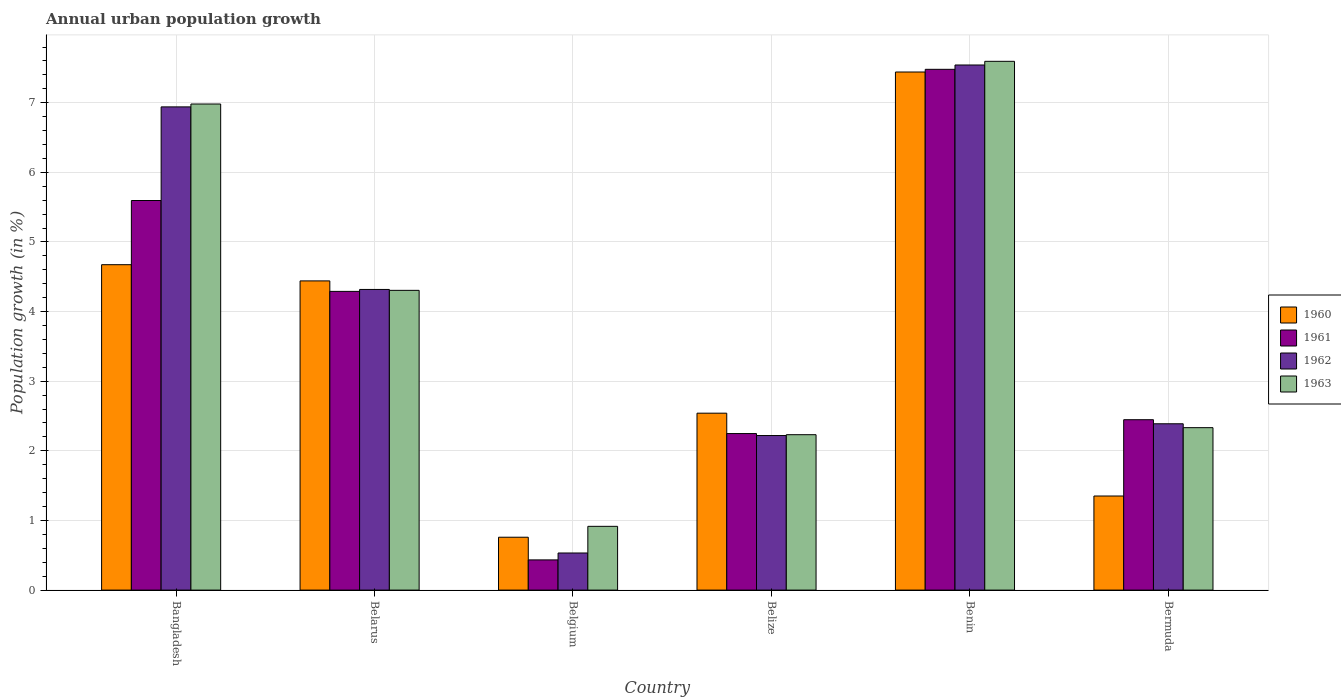Are the number of bars per tick equal to the number of legend labels?
Your response must be concise. Yes. Are the number of bars on each tick of the X-axis equal?
Provide a short and direct response. Yes. How many bars are there on the 2nd tick from the right?
Offer a very short reply. 4. What is the label of the 4th group of bars from the left?
Your answer should be compact. Belize. In how many cases, is the number of bars for a given country not equal to the number of legend labels?
Your answer should be compact. 0. What is the percentage of urban population growth in 1963 in Belarus?
Offer a very short reply. 4.31. Across all countries, what is the maximum percentage of urban population growth in 1963?
Offer a very short reply. 7.59. Across all countries, what is the minimum percentage of urban population growth in 1962?
Give a very brief answer. 0.53. In which country was the percentage of urban population growth in 1960 maximum?
Provide a succinct answer. Benin. In which country was the percentage of urban population growth in 1961 minimum?
Your answer should be compact. Belgium. What is the total percentage of urban population growth in 1963 in the graph?
Provide a short and direct response. 24.36. What is the difference between the percentage of urban population growth in 1963 in Bangladesh and that in Belarus?
Ensure brevity in your answer.  2.68. What is the difference between the percentage of urban population growth in 1960 in Belarus and the percentage of urban population growth in 1962 in Benin?
Offer a terse response. -3.1. What is the average percentage of urban population growth in 1962 per country?
Your answer should be very brief. 3.99. What is the difference between the percentage of urban population growth of/in 1962 and percentage of urban population growth of/in 1960 in Bangladesh?
Provide a short and direct response. 2.27. What is the ratio of the percentage of urban population growth in 1963 in Belize to that in Bermuda?
Give a very brief answer. 0.96. What is the difference between the highest and the second highest percentage of urban population growth in 1963?
Provide a short and direct response. -2.68. What is the difference between the highest and the lowest percentage of urban population growth in 1960?
Provide a short and direct response. 6.68. In how many countries, is the percentage of urban population growth in 1960 greater than the average percentage of urban population growth in 1960 taken over all countries?
Offer a terse response. 3. Is the sum of the percentage of urban population growth in 1960 in Belgium and Bermuda greater than the maximum percentage of urban population growth in 1961 across all countries?
Give a very brief answer. No. How many bars are there?
Make the answer very short. 24. Are all the bars in the graph horizontal?
Your answer should be compact. No. Does the graph contain grids?
Make the answer very short. Yes. Where does the legend appear in the graph?
Your answer should be compact. Center right. How many legend labels are there?
Keep it short and to the point. 4. How are the legend labels stacked?
Your answer should be very brief. Vertical. What is the title of the graph?
Make the answer very short. Annual urban population growth. What is the label or title of the Y-axis?
Ensure brevity in your answer.  Population growth (in %). What is the Population growth (in %) of 1960 in Bangladesh?
Your response must be concise. 4.67. What is the Population growth (in %) of 1961 in Bangladesh?
Make the answer very short. 5.6. What is the Population growth (in %) of 1962 in Bangladesh?
Provide a short and direct response. 6.94. What is the Population growth (in %) of 1963 in Bangladesh?
Your answer should be compact. 6.98. What is the Population growth (in %) in 1960 in Belarus?
Keep it short and to the point. 4.44. What is the Population growth (in %) in 1961 in Belarus?
Your answer should be compact. 4.29. What is the Population growth (in %) in 1962 in Belarus?
Ensure brevity in your answer.  4.32. What is the Population growth (in %) of 1963 in Belarus?
Offer a very short reply. 4.31. What is the Population growth (in %) in 1960 in Belgium?
Provide a short and direct response. 0.76. What is the Population growth (in %) in 1961 in Belgium?
Make the answer very short. 0.43. What is the Population growth (in %) of 1962 in Belgium?
Your answer should be very brief. 0.53. What is the Population growth (in %) in 1963 in Belgium?
Your answer should be compact. 0.92. What is the Population growth (in %) in 1960 in Belize?
Give a very brief answer. 2.54. What is the Population growth (in %) of 1961 in Belize?
Your answer should be compact. 2.25. What is the Population growth (in %) of 1962 in Belize?
Provide a succinct answer. 2.22. What is the Population growth (in %) of 1963 in Belize?
Your response must be concise. 2.23. What is the Population growth (in %) in 1960 in Benin?
Give a very brief answer. 7.44. What is the Population growth (in %) in 1961 in Benin?
Your answer should be compact. 7.48. What is the Population growth (in %) of 1962 in Benin?
Make the answer very short. 7.54. What is the Population growth (in %) of 1963 in Benin?
Give a very brief answer. 7.59. What is the Population growth (in %) in 1960 in Bermuda?
Your response must be concise. 1.35. What is the Population growth (in %) in 1961 in Bermuda?
Give a very brief answer. 2.45. What is the Population growth (in %) in 1962 in Bermuda?
Ensure brevity in your answer.  2.39. What is the Population growth (in %) of 1963 in Bermuda?
Your answer should be very brief. 2.33. Across all countries, what is the maximum Population growth (in %) of 1960?
Give a very brief answer. 7.44. Across all countries, what is the maximum Population growth (in %) of 1961?
Make the answer very short. 7.48. Across all countries, what is the maximum Population growth (in %) of 1962?
Make the answer very short. 7.54. Across all countries, what is the maximum Population growth (in %) in 1963?
Provide a succinct answer. 7.59. Across all countries, what is the minimum Population growth (in %) of 1960?
Keep it short and to the point. 0.76. Across all countries, what is the minimum Population growth (in %) in 1961?
Offer a terse response. 0.43. Across all countries, what is the minimum Population growth (in %) in 1962?
Provide a succinct answer. 0.53. Across all countries, what is the minimum Population growth (in %) of 1963?
Keep it short and to the point. 0.92. What is the total Population growth (in %) of 1960 in the graph?
Provide a short and direct response. 21.21. What is the total Population growth (in %) in 1961 in the graph?
Your answer should be very brief. 22.5. What is the total Population growth (in %) in 1962 in the graph?
Your answer should be very brief. 23.94. What is the total Population growth (in %) in 1963 in the graph?
Your answer should be very brief. 24.36. What is the difference between the Population growth (in %) in 1960 in Bangladesh and that in Belarus?
Your response must be concise. 0.23. What is the difference between the Population growth (in %) of 1961 in Bangladesh and that in Belarus?
Your answer should be very brief. 1.31. What is the difference between the Population growth (in %) in 1962 in Bangladesh and that in Belarus?
Provide a succinct answer. 2.62. What is the difference between the Population growth (in %) of 1963 in Bangladesh and that in Belarus?
Make the answer very short. 2.68. What is the difference between the Population growth (in %) of 1960 in Bangladesh and that in Belgium?
Keep it short and to the point. 3.91. What is the difference between the Population growth (in %) in 1961 in Bangladesh and that in Belgium?
Your answer should be very brief. 5.16. What is the difference between the Population growth (in %) of 1962 in Bangladesh and that in Belgium?
Your response must be concise. 6.41. What is the difference between the Population growth (in %) in 1963 in Bangladesh and that in Belgium?
Offer a very short reply. 6.07. What is the difference between the Population growth (in %) of 1960 in Bangladesh and that in Belize?
Offer a terse response. 2.13. What is the difference between the Population growth (in %) of 1961 in Bangladesh and that in Belize?
Make the answer very short. 3.35. What is the difference between the Population growth (in %) in 1962 in Bangladesh and that in Belize?
Provide a succinct answer. 4.72. What is the difference between the Population growth (in %) of 1963 in Bangladesh and that in Belize?
Make the answer very short. 4.75. What is the difference between the Population growth (in %) in 1960 in Bangladesh and that in Benin?
Ensure brevity in your answer.  -2.77. What is the difference between the Population growth (in %) of 1961 in Bangladesh and that in Benin?
Offer a terse response. -1.88. What is the difference between the Population growth (in %) of 1962 in Bangladesh and that in Benin?
Ensure brevity in your answer.  -0.6. What is the difference between the Population growth (in %) of 1963 in Bangladesh and that in Benin?
Your response must be concise. -0.61. What is the difference between the Population growth (in %) of 1960 in Bangladesh and that in Bermuda?
Provide a succinct answer. 3.32. What is the difference between the Population growth (in %) of 1961 in Bangladesh and that in Bermuda?
Your answer should be very brief. 3.15. What is the difference between the Population growth (in %) in 1962 in Bangladesh and that in Bermuda?
Keep it short and to the point. 4.55. What is the difference between the Population growth (in %) in 1963 in Bangladesh and that in Bermuda?
Keep it short and to the point. 4.65. What is the difference between the Population growth (in %) in 1960 in Belarus and that in Belgium?
Provide a succinct answer. 3.68. What is the difference between the Population growth (in %) of 1961 in Belarus and that in Belgium?
Offer a very short reply. 3.86. What is the difference between the Population growth (in %) of 1962 in Belarus and that in Belgium?
Your answer should be very brief. 3.79. What is the difference between the Population growth (in %) of 1963 in Belarus and that in Belgium?
Your response must be concise. 3.39. What is the difference between the Population growth (in %) in 1961 in Belarus and that in Belize?
Offer a very short reply. 2.04. What is the difference between the Population growth (in %) in 1962 in Belarus and that in Belize?
Keep it short and to the point. 2.1. What is the difference between the Population growth (in %) of 1963 in Belarus and that in Belize?
Your answer should be compact. 2.07. What is the difference between the Population growth (in %) in 1960 in Belarus and that in Benin?
Offer a terse response. -3. What is the difference between the Population growth (in %) in 1961 in Belarus and that in Benin?
Provide a short and direct response. -3.19. What is the difference between the Population growth (in %) of 1962 in Belarus and that in Benin?
Provide a succinct answer. -3.22. What is the difference between the Population growth (in %) of 1963 in Belarus and that in Benin?
Make the answer very short. -3.29. What is the difference between the Population growth (in %) of 1960 in Belarus and that in Bermuda?
Offer a terse response. 3.09. What is the difference between the Population growth (in %) of 1961 in Belarus and that in Bermuda?
Your answer should be very brief. 1.84. What is the difference between the Population growth (in %) in 1962 in Belarus and that in Bermuda?
Your answer should be compact. 1.93. What is the difference between the Population growth (in %) in 1963 in Belarus and that in Bermuda?
Your response must be concise. 1.97. What is the difference between the Population growth (in %) in 1960 in Belgium and that in Belize?
Provide a succinct answer. -1.78. What is the difference between the Population growth (in %) in 1961 in Belgium and that in Belize?
Your response must be concise. -1.81. What is the difference between the Population growth (in %) in 1962 in Belgium and that in Belize?
Provide a succinct answer. -1.69. What is the difference between the Population growth (in %) of 1963 in Belgium and that in Belize?
Your answer should be compact. -1.32. What is the difference between the Population growth (in %) of 1960 in Belgium and that in Benin?
Provide a succinct answer. -6.68. What is the difference between the Population growth (in %) in 1961 in Belgium and that in Benin?
Keep it short and to the point. -7.05. What is the difference between the Population growth (in %) of 1962 in Belgium and that in Benin?
Keep it short and to the point. -7.01. What is the difference between the Population growth (in %) of 1963 in Belgium and that in Benin?
Your answer should be compact. -6.68. What is the difference between the Population growth (in %) in 1960 in Belgium and that in Bermuda?
Your response must be concise. -0.59. What is the difference between the Population growth (in %) of 1961 in Belgium and that in Bermuda?
Provide a short and direct response. -2.01. What is the difference between the Population growth (in %) in 1962 in Belgium and that in Bermuda?
Your answer should be compact. -1.86. What is the difference between the Population growth (in %) in 1963 in Belgium and that in Bermuda?
Provide a short and direct response. -1.42. What is the difference between the Population growth (in %) in 1960 in Belize and that in Benin?
Make the answer very short. -4.9. What is the difference between the Population growth (in %) in 1961 in Belize and that in Benin?
Give a very brief answer. -5.23. What is the difference between the Population growth (in %) of 1962 in Belize and that in Benin?
Make the answer very short. -5.32. What is the difference between the Population growth (in %) in 1963 in Belize and that in Benin?
Keep it short and to the point. -5.36. What is the difference between the Population growth (in %) in 1960 in Belize and that in Bermuda?
Make the answer very short. 1.19. What is the difference between the Population growth (in %) in 1961 in Belize and that in Bermuda?
Provide a succinct answer. -0.2. What is the difference between the Population growth (in %) in 1962 in Belize and that in Bermuda?
Make the answer very short. -0.17. What is the difference between the Population growth (in %) in 1963 in Belize and that in Bermuda?
Give a very brief answer. -0.1. What is the difference between the Population growth (in %) of 1960 in Benin and that in Bermuda?
Offer a terse response. 6.09. What is the difference between the Population growth (in %) in 1961 in Benin and that in Bermuda?
Your answer should be compact. 5.03. What is the difference between the Population growth (in %) of 1962 in Benin and that in Bermuda?
Provide a succinct answer. 5.15. What is the difference between the Population growth (in %) in 1963 in Benin and that in Bermuda?
Give a very brief answer. 5.26. What is the difference between the Population growth (in %) of 1960 in Bangladesh and the Population growth (in %) of 1961 in Belarus?
Offer a very short reply. 0.38. What is the difference between the Population growth (in %) in 1960 in Bangladesh and the Population growth (in %) in 1962 in Belarus?
Your response must be concise. 0.36. What is the difference between the Population growth (in %) in 1960 in Bangladesh and the Population growth (in %) in 1963 in Belarus?
Ensure brevity in your answer.  0.37. What is the difference between the Population growth (in %) of 1961 in Bangladesh and the Population growth (in %) of 1962 in Belarus?
Offer a very short reply. 1.28. What is the difference between the Population growth (in %) of 1961 in Bangladesh and the Population growth (in %) of 1963 in Belarus?
Your answer should be very brief. 1.29. What is the difference between the Population growth (in %) of 1962 in Bangladesh and the Population growth (in %) of 1963 in Belarus?
Offer a terse response. 2.63. What is the difference between the Population growth (in %) of 1960 in Bangladesh and the Population growth (in %) of 1961 in Belgium?
Provide a succinct answer. 4.24. What is the difference between the Population growth (in %) in 1960 in Bangladesh and the Population growth (in %) in 1962 in Belgium?
Offer a terse response. 4.14. What is the difference between the Population growth (in %) of 1960 in Bangladesh and the Population growth (in %) of 1963 in Belgium?
Make the answer very short. 3.76. What is the difference between the Population growth (in %) in 1961 in Bangladesh and the Population growth (in %) in 1962 in Belgium?
Give a very brief answer. 5.06. What is the difference between the Population growth (in %) of 1961 in Bangladesh and the Population growth (in %) of 1963 in Belgium?
Ensure brevity in your answer.  4.68. What is the difference between the Population growth (in %) of 1962 in Bangladesh and the Population growth (in %) of 1963 in Belgium?
Provide a short and direct response. 6.02. What is the difference between the Population growth (in %) of 1960 in Bangladesh and the Population growth (in %) of 1961 in Belize?
Give a very brief answer. 2.43. What is the difference between the Population growth (in %) in 1960 in Bangladesh and the Population growth (in %) in 1962 in Belize?
Give a very brief answer. 2.45. What is the difference between the Population growth (in %) in 1960 in Bangladesh and the Population growth (in %) in 1963 in Belize?
Your answer should be very brief. 2.44. What is the difference between the Population growth (in %) in 1961 in Bangladesh and the Population growth (in %) in 1962 in Belize?
Offer a terse response. 3.38. What is the difference between the Population growth (in %) of 1961 in Bangladesh and the Population growth (in %) of 1963 in Belize?
Offer a very short reply. 3.36. What is the difference between the Population growth (in %) in 1962 in Bangladesh and the Population growth (in %) in 1963 in Belize?
Offer a very short reply. 4.71. What is the difference between the Population growth (in %) of 1960 in Bangladesh and the Population growth (in %) of 1961 in Benin?
Make the answer very short. -2.81. What is the difference between the Population growth (in %) in 1960 in Bangladesh and the Population growth (in %) in 1962 in Benin?
Your answer should be very brief. -2.87. What is the difference between the Population growth (in %) of 1960 in Bangladesh and the Population growth (in %) of 1963 in Benin?
Your response must be concise. -2.92. What is the difference between the Population growth (in %) of 1961 in Bangladesh and the Population growth (in %) of 1962 in Benin?
Your answer should be compact. -1.95. What is the difference between the Population growth (in %) in 1961 in Bangladesh and the Population growth (in %) in 1963 in Benin?
Offer a very short reply. -2. What is the difference between the Population growth (in %) of 1962 in Bangladesh and the Population growth (in %) of 1963 in Benin?
Provide a succinct answer. -0.65. What is the difference between the Population growth (in %) in 1960 in Bangladesh and the Population growth (in %) in 1961 in Bermuda?
Offer a terse response. 2.23. What is the difference between the Population growth (in %) in 1960 in Bangladesh and the Population growth (in %) in 1962 in Bermuda?
Your answer should be very brief. 2.28. What is the difference between the Population growth (in %) in 1960 in Bangladesh and the Population growth (in %) in 1963 in Bermuda?
Offer a very short reply. 2.34. What is the difference between the Population growth (in %) of 1961 in Bangladesh and the Population growth (in %) of 1962 in Bermuda?
Keep it short and to the point. 3.21. What is the difference between the Population growth (in %) of 1961 in Bangladesh and the Population growth (in %) of 1963 in Bermuda?
Ensure brevity in your answer.  3.26. What is the difference between the Population growth (in %) of 1962 in Bangladesh and the Population growth (in %) of 1963 in Bermuda?
Provide a short and direct response. 4.61. What is the difference between the Population growth (in %) of 1960 in Belarus and the Population growth (in %) of 1961 in Belgium?
Provide a succinct answer. 4.01. What is the difference between the Population growth (in %) of 1960 in Belarus and the Population growth (in %) of 1962 in Belgium?
Your answer should be compact. 3.91. What is the difference between the Population growth (in %) in 1960 in Belarus and the Population growth (in %) in 1963 in Belgium?
Your answer should be compact. 3.53. What is the difference between the Population growth (in %) in 1961 in Belarus and the Population growth (in %) in 1962 in Belgium?
Your response must be concise. 3.76. What is the difference between the Population growth (in %) in 1961 in Belarus and the Population growth (in %) in 1963 in Belgium?
Provide a succinct answer. 3.37. What is the difference between the Population growth (in %) of 1962 in Belarus and the Population growth (in %) of 1963 in Belgium?
Provide a short and direct response. 3.4. What is the difference between the Population growth (in %) of 1960 in Belarus and the Population growth (in %) of 1961 in Belize?
Your answer should be very brief. 2.19. What is the difference between the Population growth (in %) in 1960 in Belarus and the Population growth (in %) in 1962 in Belize?
Make the answer very short. 2.22. What is the difference between the Population growth (in %) in 1960 in Belarus and the Population growth (in %) in 1963 in Belize?
Ensure brevity in your answer.  2.21. What is the difference between the Population growth (in %) of 1961 in Belarus and the Population growth (in %) of 1962 in Belize?
Offer a very short reply. 2.07. What is the difference between the Population growth (in %) of 1961 in Belarus and the Population growth (in %) of 1963 in Belize?
Offer a terse response. 2.06. What is the difference between the Population growth (in %) in 1962 in Belarus and the Population growth (in %) in 1963 in Belize?
Ensure brevity in your answer.  2.09. What is the difference between the Population growth (in %) of 1960 in Belarus and the Population growth (in %) of 1961 in Benin?
Your response must be concise. -3.04. What is the difference between the Population growth (in %) of 1960 in Belarus and the Population growth (in %) of 1962 in Benin?
Make the answer very short. -3.1. What is the difference between the Population growth (in %) of 1960 in Belarus and the Population growth (in %) of 1963 in Benin?
Your answer should be very brief. -3.15. What is the difference between the Population growth (in %) in 1961 in Belarus and the Population growth (in %) in 1962 in Benin?
Your response must be concise. -3.25. What is the difference between the Population growth (in %) in 1961 in Belarus and the Population growth (in %) in 1963 in Benin?
Make the answer very short. -3.3. What is the difference between the Population growth (in %) of 1962 in Belarus and the Population growth (in %) of 1963 in Benin?
Your answer should be compact. -3.28. What is the difference between the Population growth (in %) in 1960 in Belarus and the Population growth (in %) in 1961 in Bermuda?
Provide a short and direct response. 1.99. What is the difference between the Population growth (in %) in 1960 in Belarus and the Population growth (in %) in 1962 in Bermuda?
Offer a terse response. 2.05. What is the difference between the Population growth (in %) of 1960 in Belarus and the Population growth (in %) of 1963 in Bermuda?
Your answer should be compact. 2.11. What is the difference between the Population growth (in %) of 1961 in Belarus and the Population growth (in %) of 1962 in Bermuda?
Your response must be concise. 1.9. What is the difference between the Population growth (in %) in 1961 in Belarus and the Population growth (in %) in 1963 in Bermuda?
Offer a terse response. 1.96. What is the difference between the Population growth (in %) in 1962 in Belarus and the Population growth (in %) in 1963 in Bermuda?
Offer a terse response. 1.99. What is the difference between the Population growth (in %) in 1960 in Belgium and the Population growth (in %) in 1961 in Belize?
Make the answer very short. -1.49. What is the difference between the Population growth (in %) in 1960 in Belgium and the Population growth (in %) in 1962 in Belize?
Ensure brevity in your answer.  -1.46. What is the difference between the Population growth (in %) of 1960 in Belgium and the Population growth (in %) of 1963 in Belize?
Offer a terse response. -1.47. What is the difference between the Population growth (in %) of 1961 in Belgium and the Population growth (in %) of 1962 in Belize?
Ensure brevity in your answer.  -1.79. What is the difference between the Population growth (in %) of 1961 in Belgium and the Population growth (in %) of 1963 in Belize?
Your response must be concise. -1.8. What is the difference between the Population growth (in %) in 1962 in Belgium and the Population growth (in %) in 1963 in Belize?
Your response must be concise. -1.7. What is the difference between the Population growth (in %) in 1960 in Belgium and the Population growth (in %) in 1961 in Benin?
Provide a succinct answer. -6.72. What is the difference between the Population growth (in %) in 1960 in Belgium and the Population growth (in %) in 1962 in Benin?
Provide a succinct answer. -6.78. What is the difference between the Population growth (in %) in 1960 in Belgium and the Population growth (in %) in 1963 in Benin?
Offer a very short reply. -6.84. What is the difference between the Population growth (in %) of 1961 in Belgium and the Population growth (in %) of 1962 in Benin?
Provide a short and direct response. -7.11. What is the difference between the Population growth (in %) of 1961 in Belgium and the Population growth (in %) of 1963 in Benin?
Provide a short and direct response. -7.16. What is the difference between the Population growth (in %) of 1962 in Belgium and the Population growth (in %) of 1963 in Benin?
Your answer should be very brief. -7.06. What is the difference between the Population growth (in %) in 1960 in Belgium and the Population growth (in %) in 1961 in Bermuda?
Offer a terse response. -1.69. What is the difference between the Population growth (in %) of 1960 in Belgium and the Population growth (in %) of 1962 in Bermuda?
Give a very brief answer. -1.63. What is the difference between the Population growth (in %) in 1960 in Belgium and the Population growth (in %) in 1963 in Bermuda?
Offer a very short reply. -1.57. What is the difference between the Population growth (in %) of 1961 in Belgium and the Population growth (in %) of 1962 in Bermuda?
Your answer should be very brief. -1.96. What is the difference between the Population growth (in %) of 1961 in Belgium and the Population growth (in %) of 1963 in Bermuda?
Provide a short and direct response. -1.9. What is the difference between the Population growth (in %) of 1962 in Belgium and the Population growth (in %) of 1963 in Bermuda?
Offer a terse response. -1.8. What is the difference between the Population growth (in %) in 1960 in Belize and the Population growth (in %) in 1961 in Benin?
Make the answer very short. -4.94. What is the difference between the Population growth (in %) of 1960 in Belize and the Population growth (in %) of 1962 in Benin?
Offer a very short reply. -5. What is the difference between the Population growth (in %) in 1960 in Belize and the Population growth (in %) in 1963 in Benin?
Make the answer very short. -5.05. What is the difference between the Population growth (in %) in 1961 in Belize and the Population growth (in %) in 1962 in Benin?
Your answer should be very brief. -5.29. What is the difference between the Population growth (in %) in 1961 in Belize and the Population growth (in %) in 1963 in Benin?
Make the answer very short. -5.35. What is the difference between the Population growth (in %) of 1962 in Belize and the Population growth (in %) of 1963 in Benin?
Provide a succinct answer. -5.37. What is the difference between the Population growth (in %) in 1960 in Belize and the Population growth (in %) in 1961 in Bermuda?
Ensure brevity in your answer.  0.09. What is the difference between the Population growth (in %) of 1960 in Belize and the Population growth (in %) of 1962 in Bermuda?
Offer a terse response. 0.15. What is the difference between the Population growth (in %) in 1960 in Belize and the Population growth (in %) in 1963 in Bermuda?
Make the answer very short. 0.21. What is the difference between the Population growth (in %) in 1961 in Belize and the Population growth (in %) in 1962 in Bermuda?
Your answer should be compact. -0.14. What is the difference between the Population growth (in %) in 1961 in Belize and the Population growth (in %) in 1963 in Bermuda?
Ensure brevity in your answer.  -0.08. What is the difference between the Population growth (in %) of 1962 in Belize and the Population growth (in %) of 1963 in Bermuda?
Your answer should be very brief. -0.11. What is the difference between the Population growth (in %) of 1960 in Benin and the Population growth (in %) of 1961 in Bermuda?
Offer a terse response. 4.99. What is the difference between the Population growth (in %) in 1960 in Benin and the Population growth (in %) in 1962 in Bermuda?
Give a very brief answer. 5.05. What is the difference between the Population growth (in %) in 1960 in Benin and the Population growth (in %) in 1963 in Bermuda?
Offer a terse response. 5.11. What is the difference between the Population growth (in %) of 1961 in Benin and the Population growth (in %) of 1962 in Bermuda?
Offer a very short reply. 5.09. What is the difference between the Population growth (in %) in 1961 in Benin and the Population growth (in %) in 1963 in Bermuda?
Provide a short and direct response. 5.15. What is the difference between the Population growth (in %) of 1962 in Benin and the Population growth (in %) of 1963 in Bermuda?
Your answer should be very brief. 5.21. What is the average Population growth (in %) of 1960 per country?
Provide a short and direct response. 3.53. What is the average Population growth (in %) of 1961 per country?
Give a very brief answer. 3.75. What is the average Population growth (in %) in 1962 per country?
Make the answer very short. 3.99. What is the average Population growth (in %) in 1963 per country?
Keep it short and to the point. 4.06. What is the difference between the Population growth (in %) of 1960 and Population growth (in %) of 1961 in Bangladesh?
Give a very brief answer. -0.92. What is the difference between the Population growth (in %) in 1960 and Population growth (in %) in 1962 in Bangladesh?
Keep it short and to the point. -2.27. What is the difference between the Population growth (in %) of 1960 and Population growth (in %) of 1963 in Bangladesh?
Ensure brevity in your answer.  -2.31. What is the difference between the Population growth (in %) of 1961 and Population growth (in %) of 1962 in Bangladesh?
Make the answer very short. -1.34. What is the difference between the Population growth (in %) in 1961 and Population growth (in %) in 1963 in Bangladesh?
Make the answer very short. -1.39. What is the difference between the Population growth (in %) of 1962 and Population growth (in %) of 1963 in Bangladesh?
Your response must be concise. -0.04. What is the difference between the Population growth (in %) in 1960 and Population growth (in %) in 1961 in Belarus?
Make the answer very short. 0.15. What is the difference between the Population growth (in %) of 1960 and Population growth (in %) of 1962 in Belarus?
Offer a very short reply. 0.12. What is the difference between the Population growth (in %) of 1960 and Population growth (in %) of 1963 in Belarus?
Make the answer very short. 0.14. What is the difference between the Population growth (in %) in 1961 and Population growth (in %) in 1962 in Belarus?
Your response must be concise. -0.03. What is the difference between the Population growth (in %) in 1961 and Population growth (in %) in 1963 in Belarus?
Your answer should be very brief. -0.01. What is the difference between the Population growth (in %) of 1962 and Population growth (in %) of 1963 in Belarus?
Your response must be concise. 0.01. What is the difference between the Population growth (in %) of 1960 and Population growth (in %) of 1961 in Belgium?
Your answer should be compact. 0.33. What is the difference between the Population growth (in %) in 1960 and Population growth (in %) in 1962 in Belgium?
Your response must be concise. 0.23. What is the difference between the Population growth (in %) in 1960 and Population growth (in %) in 1963 in Belgium?
Provide a succinct answer. -0.16. What is the difference between the Population growth (in %) in 1961 and Population growth (in %) in 1962 in Belgium?
Your response must be concise. -0.1. What is the difference between the Population growth (in %) in 1961 and Population growth (in %) in 1963 in Belgium?
Make the answer very short. -0.48. What is the difference between the Population growth (in %) of 1962 and Population growth (in %) of 1963 in Belgium?
Make the answer very short. -0.38. What is the difference between the Population growth (in %) of 1960 and Population growth (in %) of 1961 in Belize?
Provide a short and direct response. 0.29. What is the difference between the Population growth (in %) in 1960 and Population growth (in %) in 1962 in Belize?
Offer a very short reply. 0.32. What is the difference between the Population growth (in %) of 1960 and Population growth (in %) of 1963 in Belize?
Provide a succinct answer. 0.31. What is the difference between the Population growth (in %) in 1961 and Population growth (in %) in 1962 in Belize?
Provide a succinct answer. 0.03. What is the difference between the Population growth (in %) of 1961 and Population growth (in %) of 1963 in Belize?
Your answer should be very brief. 0.02. What is the difference between the Population growth (in %) in 1962 and Population growth (in %) in 1963 in Belize?
Ensure brevity in your answer.  -0.01. What is the difference between the Population growth (in %) in 1960 and Population growth (in %) in 1961 in Benin?
Provide a short and direct response. -0.04. What is the difference between the Population growth (in %) of 1960 and Population growth (in %) of 1962 in Benin?
Give a very brief answer. -0.1. What is the difference between the Population growth (in %) in 1960 and Population growth (in %) in 1963 in Benin?
Offer a terse response. -0.15. What is the difference between the Population growth (in %) in 1961 and Population growth (in %) in 1962 in Benin?
Keep it short and to the point. -0.06. What is the difference between the Population growth (in %) in 1961 and Population growth (in %) in 1963 in Benin?
Your response must be concise. -0.12. What is the difference between the Population growth (in %) of 1962 and Population growth (in %) of 1963 in Benin?
Make the answer very short. -0.05. What is the difference between the Population growth (in %) of 1960 and Population growth (in %) of 1961 in Bermuda?
Make the answer very short. -1.1. What is the difference between the Population growth (in %) of 1960 and Population growth (in %) of 1962 in Bermuda?
Your answer should be compact. -1.04. What is the difference between the Population growth (in %) of 1960 and Population growth (in %) of 1963 in Bermuda?
Make the answer very short. -0.98. What is the difference between the Population growth (in %) in 1961 and Population growth (in %) in 1962 in Bermuda?
Your answer should be very brief. 0.06. What is the difference between the Population growth (in %) in 1961 and Population growth (in %) in 1963 in Bermuda?
Your response must be concise. 0.11. What is the difference between the Population growth (in %) of 1962 and Population growth (in %) of 1963 in Bermuda?
Keep it short and to the point. 0.06. What is the ratio of the Population growth (in %) in 1960 in Bangladesh to that in Belarus?
Provide a succinct answer. 1.05. What is the ratio of the Population growth (in %) of 1961 in Bangladesh to that in Belarus?
Provide a succinct answer. 1.3. What is the ratio of the Population growth (in %) of 1962 in Bangladesh to that in Belarus?
Your answer should be very brief. 1.61. What is the ratio of the Population growth (in %) of 1963 in Bangladesh to that in Belarus?
Make the answer very short. 1.62. What is the ratio of the Population growth (in %) of 1960 in Bangladesh to that in Belgium?
Keep it short and to the point. 6.15. What is the ratio of the Population growth (in %) of 1961 in Bangladesh to that in Belgium?
Ensure brevity in your answer.  12.9. What is the ratio of the Population growth (in %) of 1962 in Bangladesh to that in Belgium?
Give a very brief answer. 13.02. What is the ratio of the Population growth (in %) in 1963 in Bangladesh to that in Belgium?
Give a very brief answer. 7.62. What is the ratio of the Population growth (in %) of 1960 in Bangladesh to that in Belize?
Make the answer very short. 1.84. What is the ratio of the Population growth (in %) in 1961 in Bangladesh to that in Belize?
Give a very brief answer. 2.49. What is the ratio of the Population growth (in %) of 1962 in Bangladesh to that in Belize?
Your response must be concise. 3.13. What is the ratio of the Population growth (in %) of 1963 in Bangladesh to that in Belize?
Give a very brief answer. 3.13. What is the ratio of the Population growth (in %) of 1960 in Bangladesh to that in Benin?
Your response must be concise. 0.63. What is the ratio of the Population growth (in %) in 1961 in Bangladesh to that in Benin?
Your answer should be very brief. 0.75. What is the ratio of the Population growth (in %) in 1962 in Bangladesh to that in Benin?
Ensure brevity in your answer.  0.92. What is the ratio of the Population growth (in %) of 1963 in Bangladesh to that in Benin?
Offer a very short reply. 0.92. What is the ratio of the Population growth (in %) in 1960 in Bangladesh to that in Bermuda?
Your response must be concise. 3.46. What is the ratio of the Population growth (in %) of 1961 in Bangladesh to that in Bermuda?
Your response must be concise. 2.29. What is the ratio of the Population growth (in %) of 1962 in Bangladesh to that in Bermuda?
Your answer should be very brief. 2.91. What is the ratio of the Population growth (in %) of 1963 in Bangladesh to that in Bermuda?
Ensure brevity in your answer.  2.99. What is the ratio of the Population growth (in %) of 1960 in Belarus to that in Belgium?
Make the answer very short. 5.85. What is the ratio of the Population growth (in %) in 1961 in Belarus to that in Belgium?
Offer a terse response. 9.89. What is the ratio of the Population growth (in %) of 1962 in Belarus to that in Belgium?
Your response must be concise. 8.1. What is the ratio of the Population growth (in %) of 1963 in Belarus to that in Belgium?
Give a very brief answer. 4.7. What is the ratio of the Population growth (in %) in 1960 in Belarus to that in Belize?
Provide a succinct answer. 1.75. What is the ratio of the Population growth (in %) of 1961 in Belarus to that in Belize?
Provide a short and direct response. 1.91. What is the ratio of the Population growth (in %) in 1962 in Belarus to that in Belize?
Your answer should be very brief. 1.95. What is the ratio of the Population growth (in %) in 1963 in Belarus to that in Belize?
Make the answer very short. 1.93. What is the ratio of the Population growth (in %) in 1960 in Belarus to that in Benin?
Make the answer very short. 0.6. What is the ratio of the Population growth (in %) of 1961 in Belarus to that in Benin?
Your answer should be very brief. 0.57. What is the ratio of the Population growth (in %) of 1962 in Belarus to that in Benin?
Give a very brief answer. 0.57. What is the ratio of the Population growth (in %) in 1963 in Belarus to that in Benin?
Your response must be concise. 0.57. What is the ratio of the Population growth (in %) of 1960 in Belarus to that in Bermuda?
Ensure brevity in your answer.  3.29. What is the ratio of the Population growth (in %) of 1961 in Belarus to that in Bermuda?
Provide a succinct answer. 1.75. What is the ratio of the Population growth (in %) in 1962 in Belarus to that in Bermuda?
Your response must be concise. 1.81. What is the ratio of the Population growth (in %) in 1963 in Belarus to that in Bermuda?
Provide a short and direct response. 1.85. What is the ratio of the Population growth (in %) of 1960 in Belgium to that in Belize?
Your response must be concise. 0.3. What is the ratio of the Population growth (in %) in 1961 in Belgium to that in Belize?
Provide a short and direct response. 0.19. What is the ratio of the Population growth (in %) of 1962 in Belgium to that in Belize?
Keep it short and to the point. 0.24. What is the ratio of the Population growth (in %) in 1963 in Belgium to that in Belize?
Offer a very short reply. 0.41. What is the ratio of the Population growth (in %) in 1960 in Belgium to that in Benin?
Your answer should be very brief. 0.1. What is the ratio of the Population growth (in %) of 1961 in Belgium to that in Benin?
Make the answer very short. 0.06. What is the ratio of the Population growth (in %) of 1962 in Belgium to that in Benin?
Offer a terse response. 0.07. What is the ratio of the Population growth (in %) of 1963 in Belgium to that in Benin?
Your response must be concise. 0.12. What is the ratio of the Population growth (in %) of 1960 in Belgium to that in Bermuda?
Your response must be concise. 0.56. What is the ratio of the Population growth (in %) of 1961 in Belgium to that in Bermuda?
Make the answer very short. 0.18. What is the ratio of the Population growth (in %) in 1962 in Belgium to that in Bermuda?
Your response must be concise. 0.22. What is the ratio of the Population growth (in %) of 1963 in Belgium to that in Bermuda?
Your answer should be very brief. 0.39. What is the ratio of the Population growth (in %) of 1960 in Belize to that in Benin?
Your answer should be very brief. 0.34. What is the ratio of the Population growth (in %) in 1961 in Belize to that in Benin?
Offer a very short reply. 0.3. What is the ratio of the Population growth (in %) of 1962 in Belize to that in Benin?
Offer a terse response. 0.29. What is the ratio of the Population growth (in %) in 1963 in Belize to that in Benin?
Give a very brief answer. 0.29. What is the ratio of the Population growth (in %) in 1960 in Belize to that in Bermuda?
Your answer should be compact. 1.88. What is the ratio of the Population growth (in %) in 1961 in Belize to that in Bermuda?
Offer a very short reply. 0.92. What is the ratio of the Population growth (in %) in 1962 in Belize to that in Bermuda?
Your answer should be compact. 0.93. What is the ratio of the Population growth (in %) in 1963 in Belize to that in Bermuda?
Ensure brevity in your answer.  0.96. What is the ratio of the Population growth (in %) of 1960 in Benin to that in Bermuda?
Keep it short and to the point. 5.51. What is the ratio of the Population growth (in %) in 1961 in Benin to that in Bermuda?
Your answer should be very brief. 3.06. What is the ratio of the Population growth (in %) of 1962 in Benin to that in Bermuda?
Make the answer very short. 3.16. What is the ratio of the Population growth (in %) in 1963 in Benin to that in Bermuda?
Ensure brevity in your answer.  3.26. What is the difference between the highest and the second highest Population growth (in %) in 1960?
Provide a succinct answer. 2.77. What is the difference between the highest and the second highest Population growth (in %) in 1961?
Give a very brief answer. 1.88. What is the difference between the highest and the second highest Population growth (in %) of 1962?
Give a very brief answer. 0.6. What is the difference between the highest and the second highest Population growth (in %) of 1963?
Your answer should be compact. 0.61. What is the difference between the highest and the lowest Population growth (in %) in 1960?
Make the answer very short. 6.68. What is the difference between the highest and the lowest Population growth (in %) of 1961?
Offer a very short reply. 7.05. What is the difference between the highest and the lowest Population growth (in %) of 1962?
Provide a succinct answer. 7.01. What is the difference between the highest and the lowest Population growth (in %) in 1963?
Offer a terse response. 6.68. 